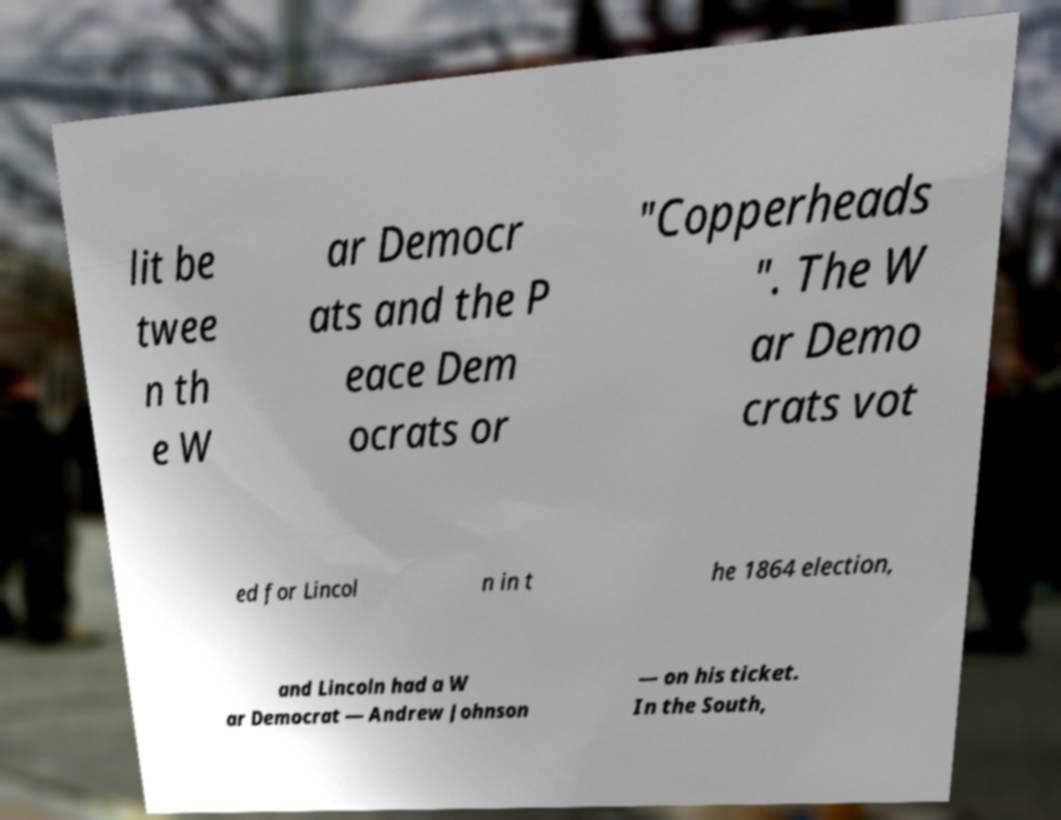Could you extract and type out the text from this image? lit be twee n th e W ar Democr ats and the P eace Dem ocrats or "Copperheads ". The W ar Demo crats vot ed for Lincol n in t he 1864 election, and Lincoln had a W ar Democrat — Andrew Johnson — on his ticket. In the South, 